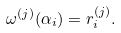<formula> <loc_0><loc_0><loc_500><loc_500>\omega ^ { ( j ) } ( \alpha _ { i } ) = r _ { i } ^ { ( j ) } .</formula> 